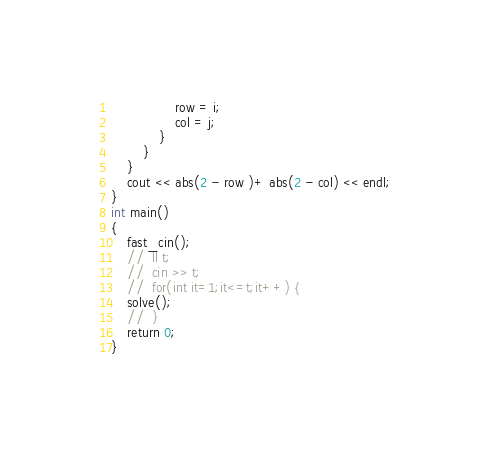<code> <loc_0><loc_0><loc_500><loc_500><_C++_>                row = i;
                col = j;
            }
        }
    }
    cout << abs(2 - row )+ abs(2 - col) << endl;
}
int main()
{
    fast_cin();
    //  ll t;
    //  cin >> t;
    //  for(int it=1;it<=t;it++) {
    solve();
    //  }
    return 0;
}</code> 